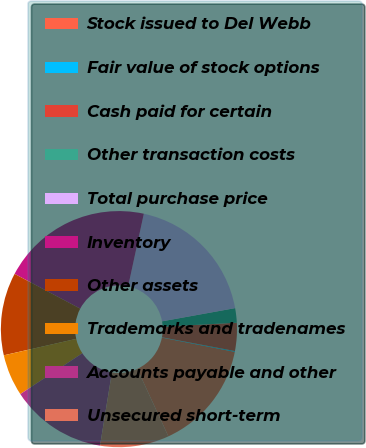<chart> <loc_0><loc_0><loc_500><loc_500><pie_chart><fcel>Stock issued to Del Webb<fcel>Fair value of stock options<fcel>Cash paid for certain<fcel>Other transaction costs<fcel>Total purchase price<fcel>Inventory<fcel>Other assets<fcel>Trademarks and tradenames<fcel>Accounts payable and other<fcel>Unsecured short-term<nl><fcel>15.04%<fcel>0.11%<fcel>3.84%<fcel>1.98%<fcel>18.77%<fcel>20.63%<fcel>11.31%<fcel>5.71%<fcel>13.17%<fcel>9.44%<nl></chart> 